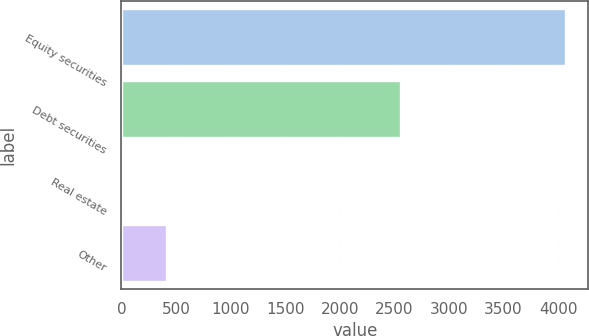Convert chart. <chart><loc_0><loc_0><loc_500><loc_500><bar_chart><fcel>Equity securities<fcel>Debt securities<fcel>Real estate<fcel>Other<nl><fcel>4075<fcel>2560<fcel>10<fcel>416.5<nl></chart> 